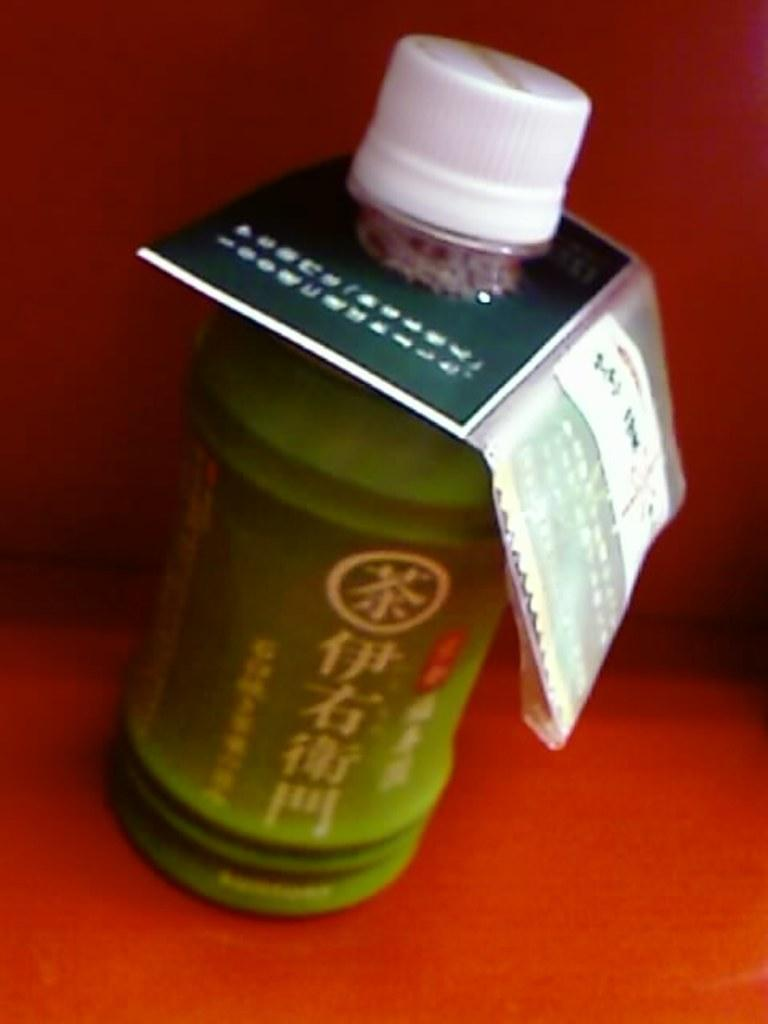What object can be seen in the image? There is a bottle in the image. What type of shoe is being used to create steam in the image? There is no shoe or steam present in the image; it only features a bottle. 